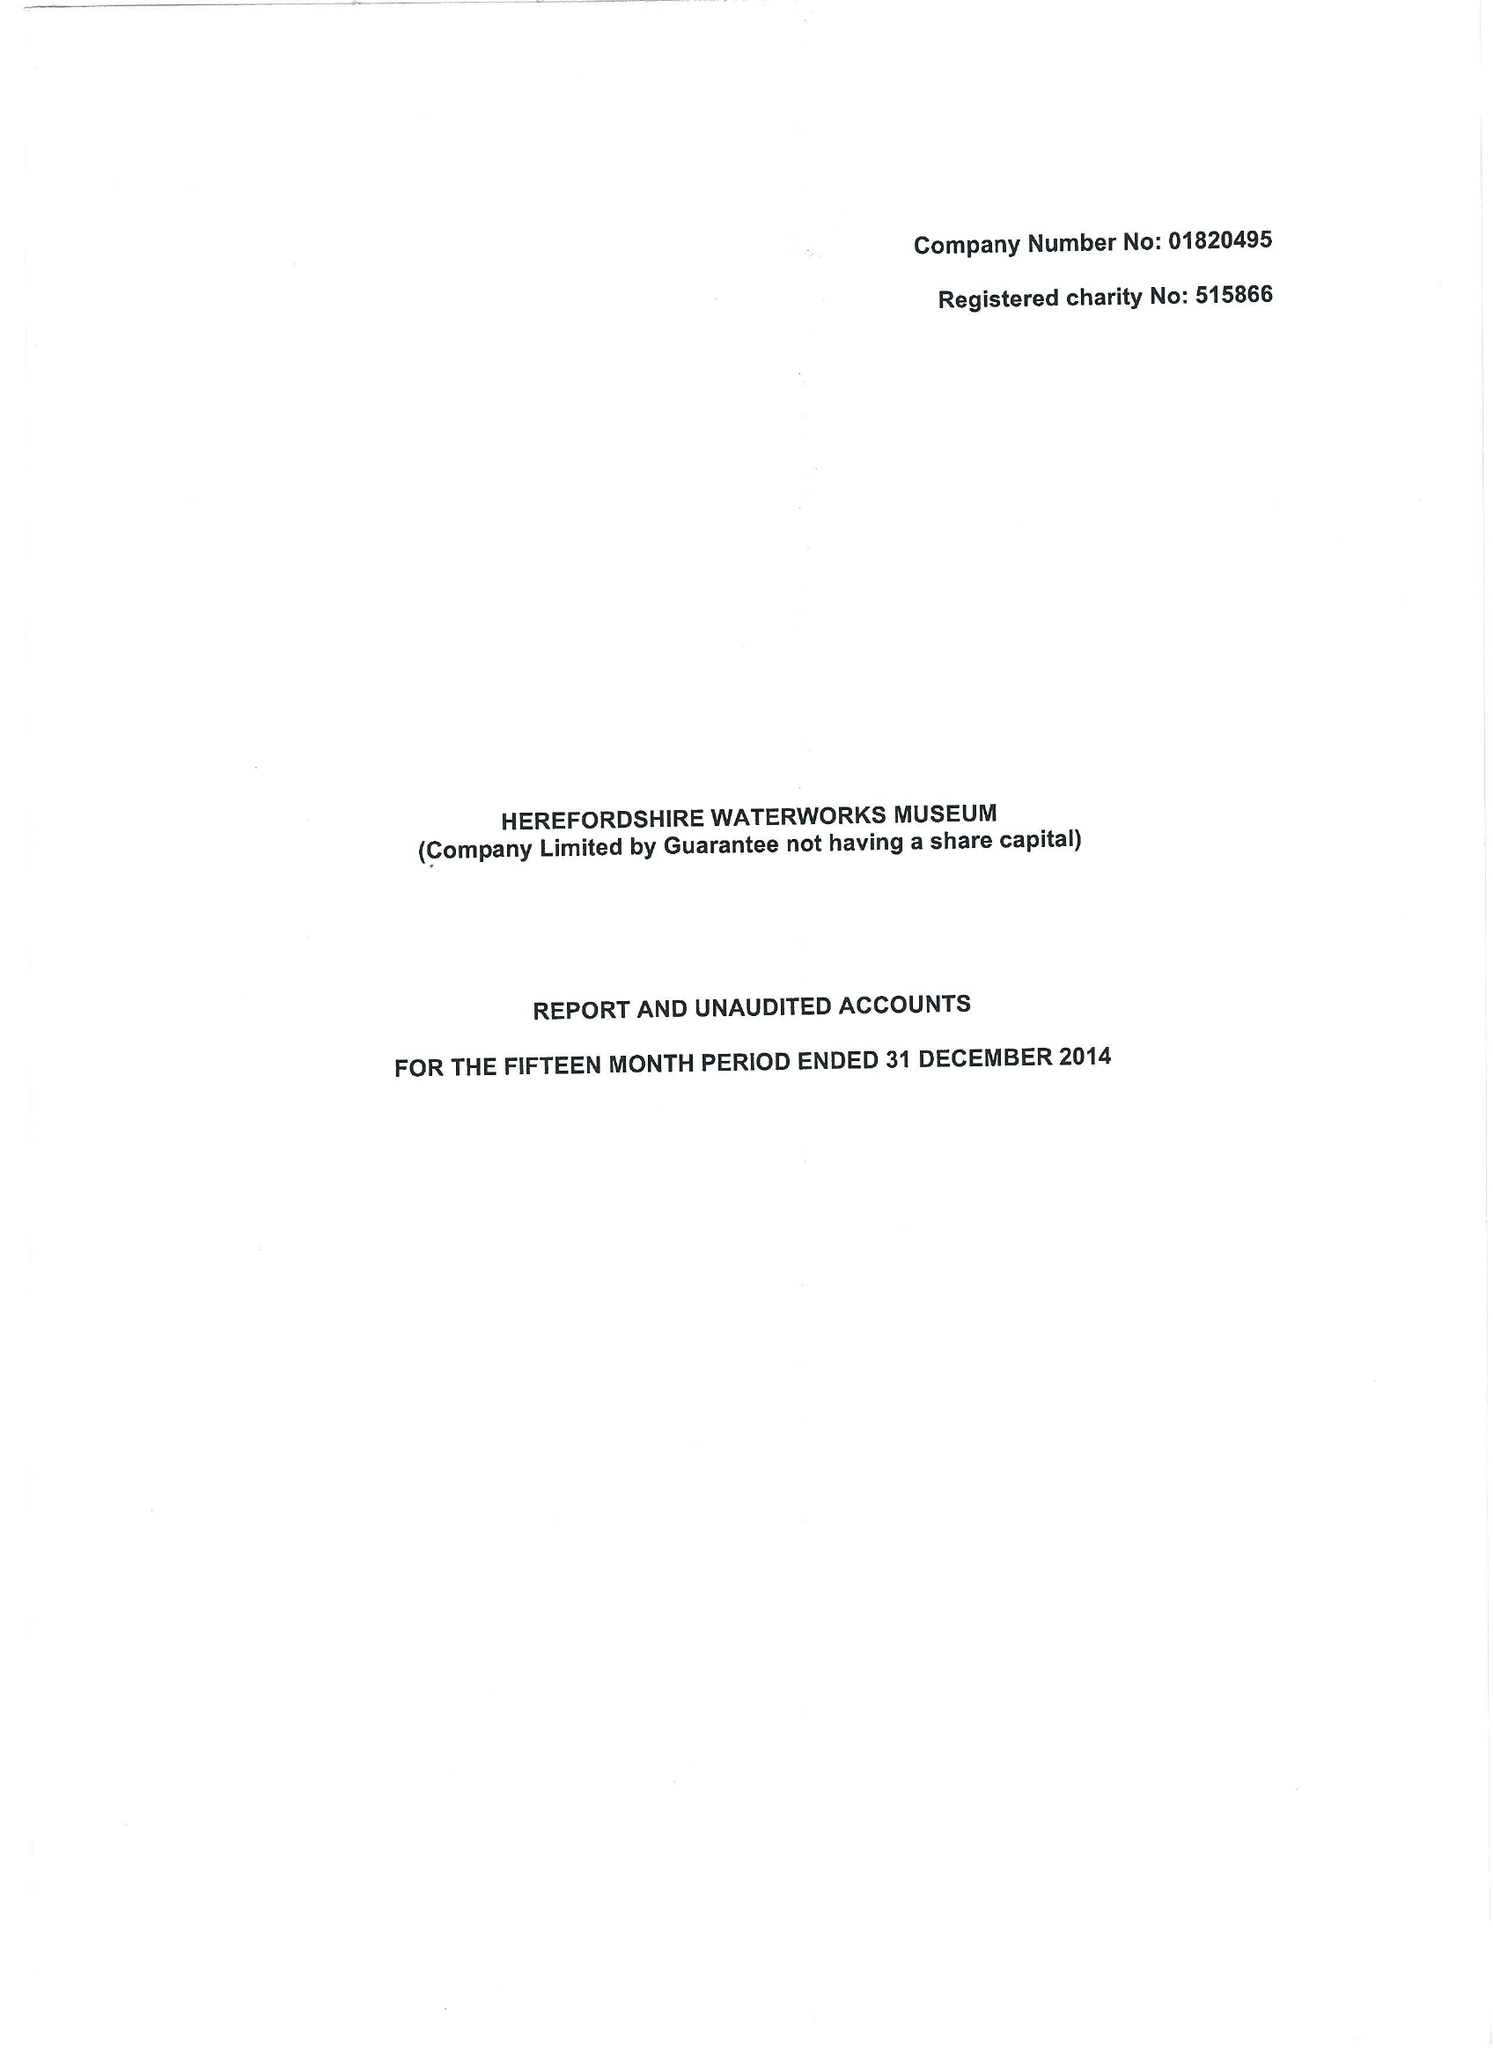What is the value for the report_date?
Answer the question using a single word or phrase. 2014-12-31 